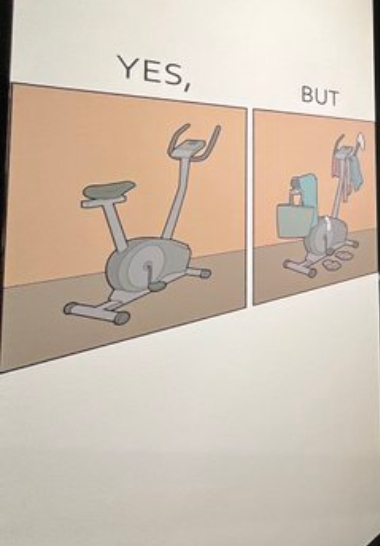Describe what you see in the left and right parts of this image. In the left part of the image: The image shows a cycling exercise machine. In the right part of the image: The image shows several things like a carry bag, clothes and towel resting or hanging on a cycling exercise machine. 